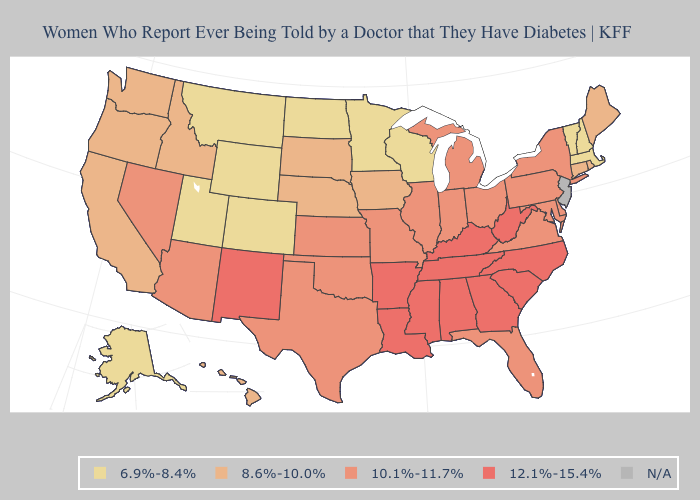Does Indiana have the lowest value in the MidWest?
Answer briefly. No. Does Washington have the lowest value in the West?
Write a very short answer. No. What is the value of Nebraska?
Write a very short answer. 8.6%-10.0%. Name the states that have a value in the range 12.1%-15.4%?
Answer briefly. Alabama, Arkansas, Georgia, Kentucky, Louisiana, Mississippi, New Mexico, North Carolina, South Carolina, Tennessee, West Virginia. Among the states that border Connecticut , does Rhode Island have the lowest value?
Quick response, please. No. Does Washington have the highest value in the West?
Write a very short answer. No. What is the value of Kentucky?
Keep it brief. 12.1%-15.4%. Name the states that have a value in the range 6.9%-8.4%?
Quick response, please. Alaska, Colorado, Massachusetts, Minnesota, Montana, New Hampshire, North Dakota, Utah, Vermont, Wisconsin, Wyoming. Among the states that border West Virginia , which have the highest value?
Give a very brief answer. Kentucky. Does the map have missing data?
Give a very brief answer. Yes. Does the first symbol in the legend represent the smallest category?
Give a very brief answer. Yes. Which states have the lowest value in the USA?
Give a very brief answer. Alaska, Colorado, Massachusetts, Minnesota, Montana, New Hampshire, North Dakota, Utah, Vermont, Wisconsin, Wyoming. Is the legend a continuous bar?
Short answer required. No. What is the lowest value in the USA?
Answer briefly. 6.9%-8.4%. Does Alabama have the highest value in the USA?
Answer briefly. Yes. 